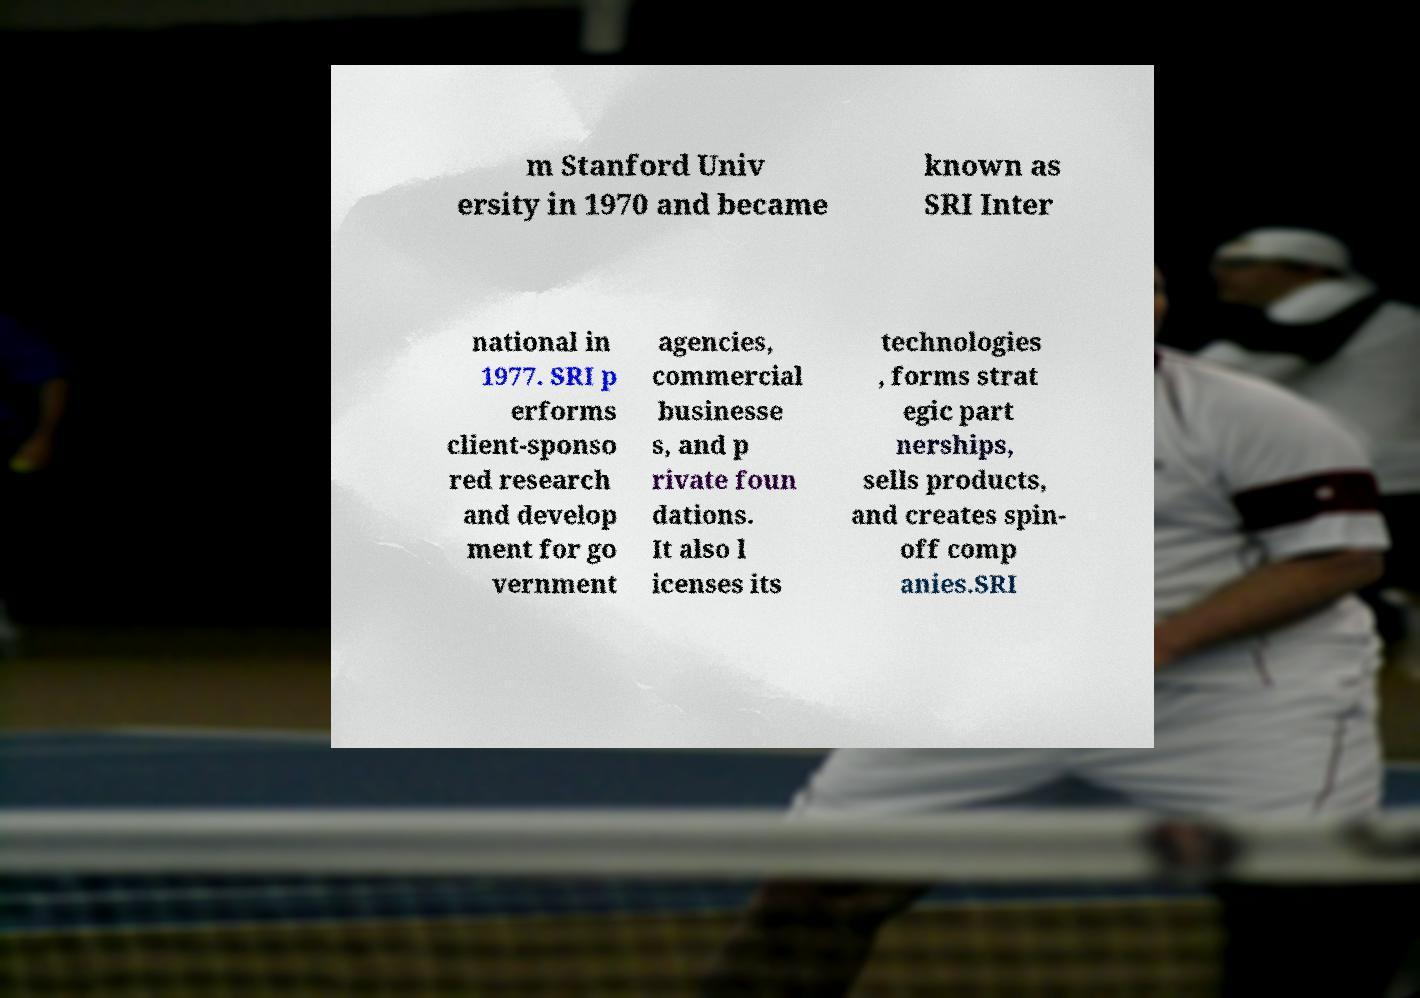Could you assist in decoding the text presented in this image and type it out clearly? m Stanford Univ ersity in 1970 and became known as SRI Inter national in 1977. SRI p erforms client-sponso red research and develop ment for go vernment agencies, commercial businesse s, and p rivate foun dations. It also l icenses its technologies , forms strat egic part nerships, sells products, and creates spin- off comp anies.SRI 